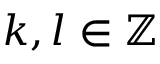<formula> <loc_0><loc_0><loc_500><loc_500>k , l \in \mathbb { Z }</formula> 